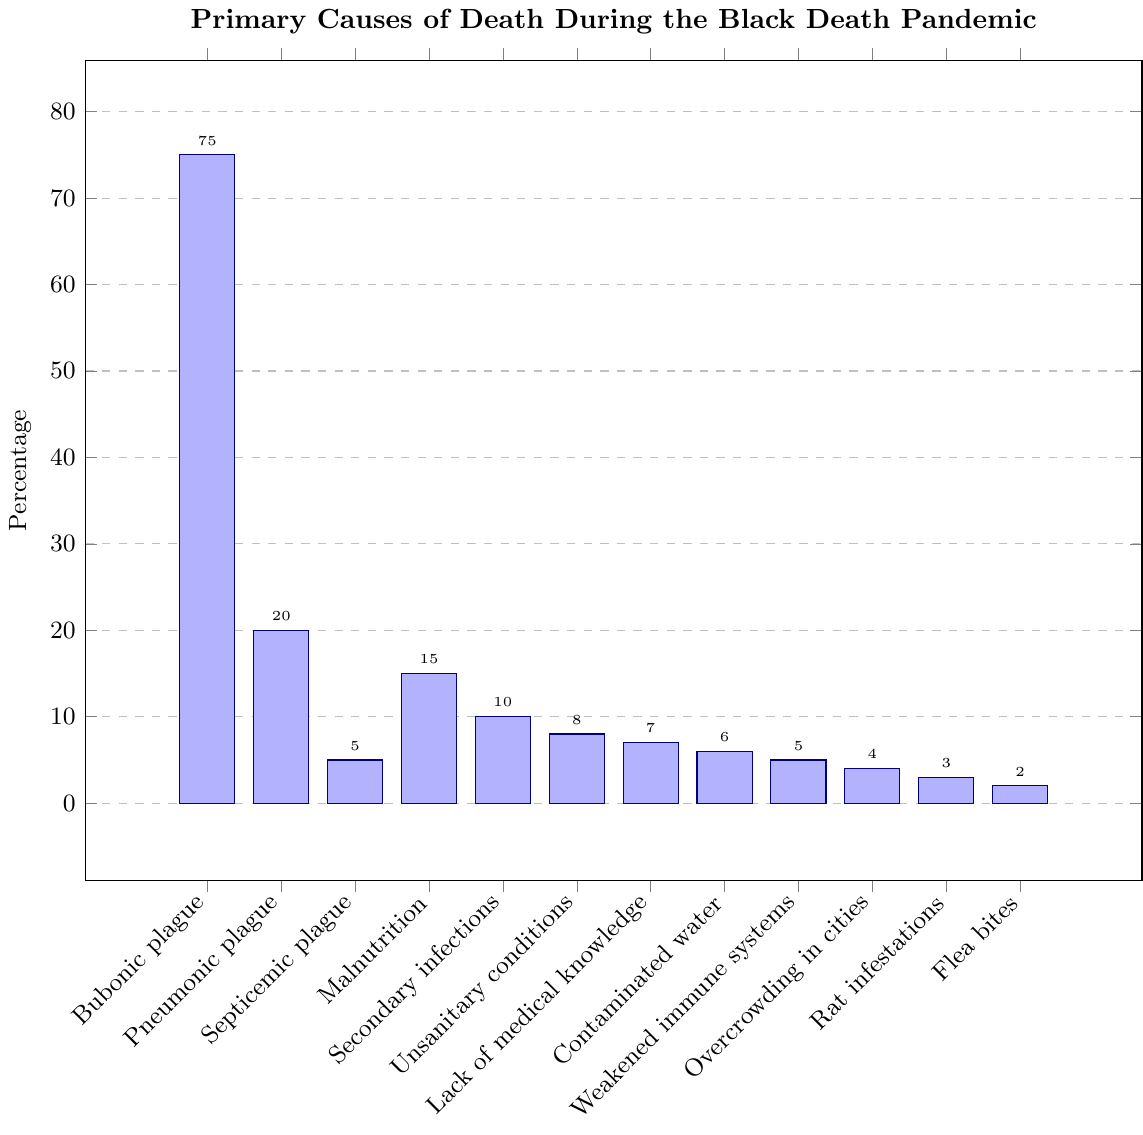Which cause of death had the highest percentage? The bar for Bubonic plague is the highest among all the causes of death. It reaches 75%.
Answer: Bubonic plague Which three causes of death had the lowest percentages? By examining the shortest bars, we see that Rat infestations (3%), Flea bites (2%), and Septicemic plague (5%) are the smallest percentages.
Answer: Rat infestations, Flea bites, Septicemic plague How much higher is the percentage of deaths from Bubonic plague compared to Pneumonic plague? The bar for Bubonic plague is 75%, and the bar for Pneumonic plague is 20%. The difference is 75% - 20% = 55%.
Answer: 55% What is the combined percentage of deaths from malnutrition and secondary infections? The bar for malnutrition is 15% and for secondary infections is 10%. Combined, they are 15% + 10% = 25%.
Answer: 25% Which cause has a lower percentage: Weakened immune systems or Overcrowding in cities? The bar for Overcrowding in cities is 4%, and the bar for Weakened immune systems is 5%. Hence, Overcrowding in cities has a lower percentage.
Answer: Overcrowding in cities What is the total percentage for all causes related to the plague (Bubonic, Pneumonic, and Septicemic)? The bars for Bubonic plague, Pneumonic plague, and Septicemic plague are 75%, 20%, and 5% respectively. Summing these, we get 75% + 20% + 5% = 100%.
Answer: 100% Which has a higher percentage: Lack of medical knowledge or Contaminated water? The bar for Lack of medical knowledge is 7%, while the bar for Contaminated water is 6%. Lack of medical knowledge is higher.
Answer: Lack of medical knowledge What is the average percentage of deaths for Unsanitary conditions, Rat infestations, and Flea bites? The bars for Unsanitary conditions, Rat infestations, and Flea bites are 8%, 3%, and 2% respectively. The average is (8% + 3% + 2%) / 3 = 13% / 3 ≈ 4.33%.
Answer: 4.33% Compare the percentages of deaths from Malnutrition and Secondary infections. Which is greater and by how much? The bar for Malnutrition is 15% and for Secondary infections is 10%. Malnutrition is greater by 15% - 10% = 5%.
Answer: Malnutrition by 5% What percentage of deaths are attributed to non-plague causes? The total percentage for non-plague causes (Malnutrition, Secondary infections, Unsanitary conditions, Lack of medical knowledge, Contaminated water, Weakened immune systems, Overcrowding in cities, Rat infestations, Flea bites) is 15% + 10% + 8% + 7% + 6% + 5% + 4% + 3% + 2% = 60%.
Answer: 60% 